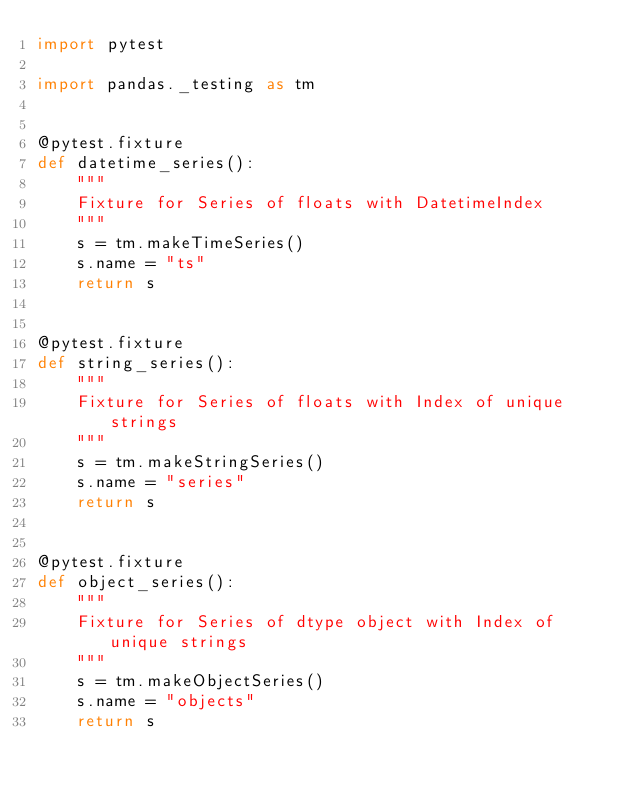<code> <loc_0><loc_0><loc_500><loc_500><_Python_>import pytest

import pandas._testing as tm


@pytest.fixture
def datetime_series():
    """
    Fixture for Series of floats with DatetimeIndex
    """
    s = tm.makeTimeSeries()
    s.name = "ts"
    return s


@pytest.fixture
def string_series():
    """
    Fixture for Series of floats with Index of unique strings
    """
    s = tm.makeStringSeries()
    s.name = "series"
    return s


@pytest.fixture
def object_series():
    """
    Fixture for Series of dtype object with Index of unique strings
    """
    s = tm.makeObjectSeries()
    s.name = "objects"
    return s
</code> 